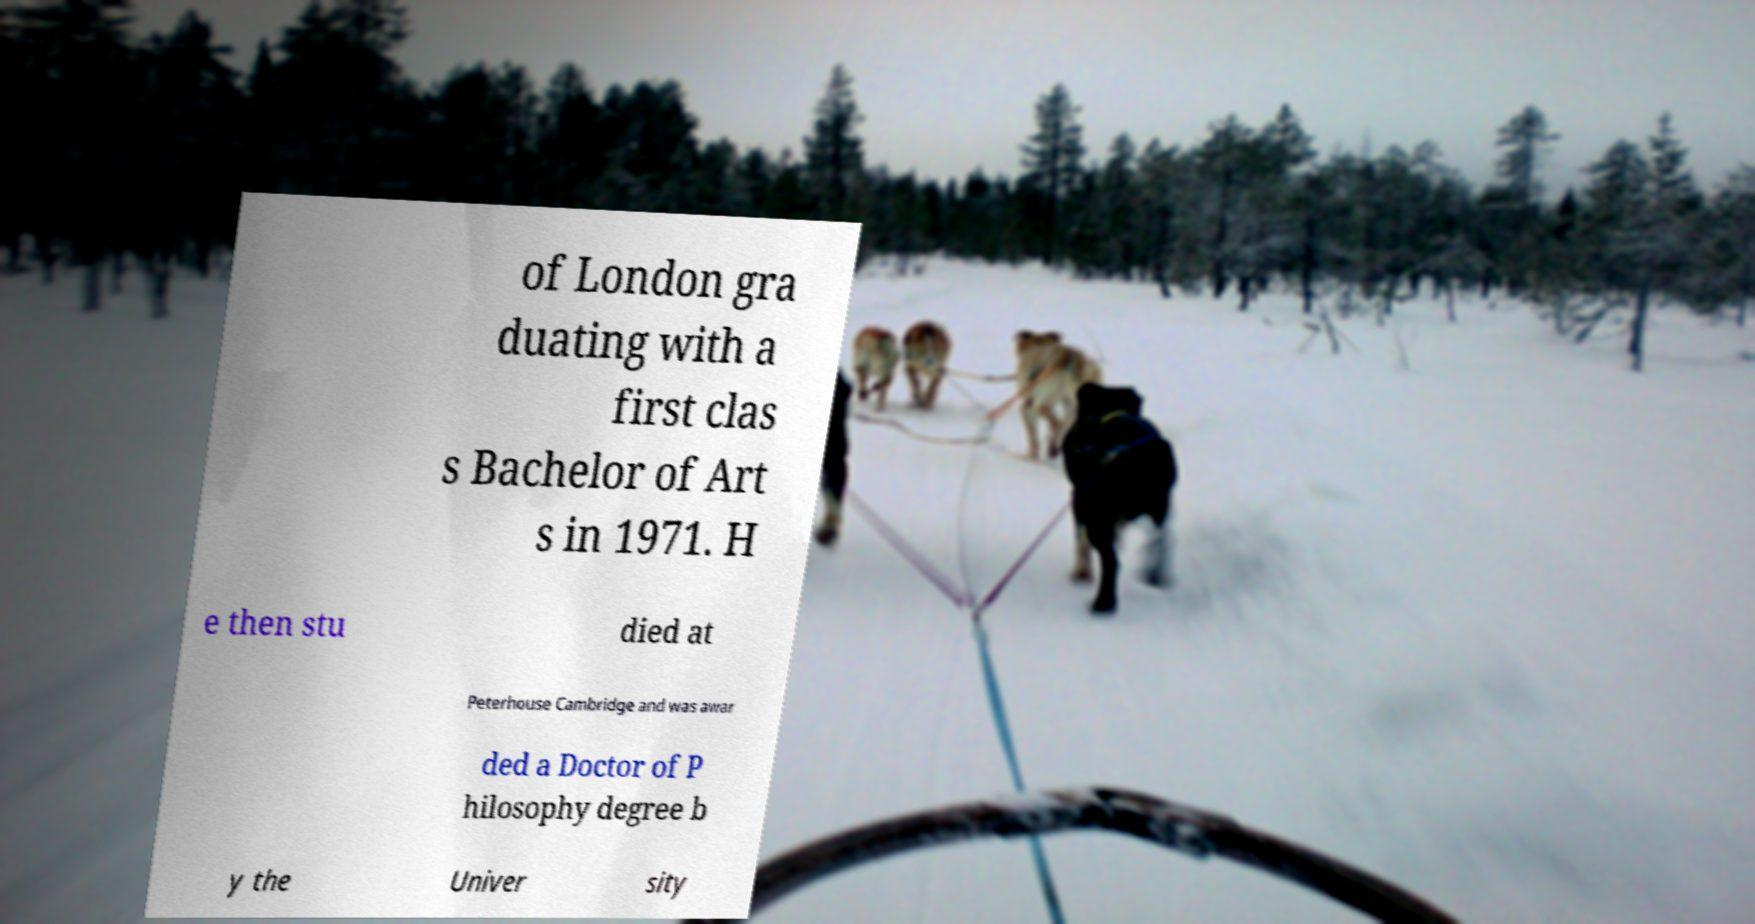Can you accurately transcribe the text from the provided image for me? of London gra duating with a first clas s Bachelor of Art s in 1971. H e then stu died at Peterhouse Cambridge and was awar ded a Doctor of P hilosophy degree b y the Univer sity 